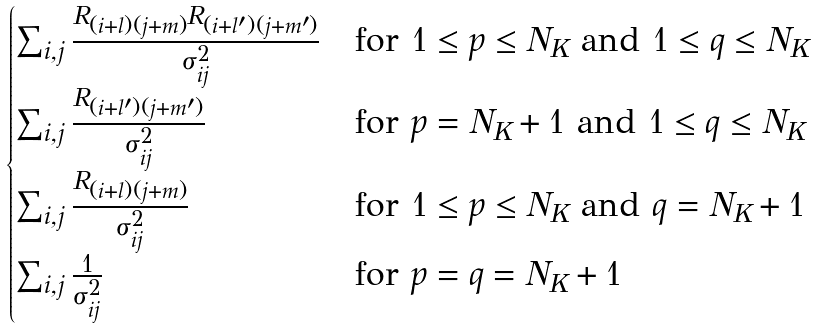Convert formula to latex. <formula><loc_0><loc_0><loc_500><loc_500>\begin{cases} \sum _ { i , j } \frac { R _ { ( i + l ) ( j + m ) } R _ { ( i + l ^ { \prime } ) ( j + m ^ { \prime } ) } } { \sigma _ { i j } ^ { 2 } } & \text {for $1 \leq p \leq N_{K}$ and $1 \leq q \leq N_{K}$} \\ \sum _ { i , j } \frac { R _ { ( i + l ^ { \prime } ) ( j + m ^ { \prime } ) } } { \sigma _ { i j } ^ { 2 } } & \text {for $p = N_{K} + 1$ and $1 \leq q \leq N_{K}$} \\ \sum _ { i , j } \frac { R _ { ( i + l ) ( j + m ) } } { \sigma _ { i j } ^ { 2 } } & \text {for $1 \leq p \leq N_{K}$ and $q = N_{K} + 1$} \\ \sum _ { i , j } \frac { 1 } { \sigma _ { i j } ^ { 2 } } & \text {for $p = q = N_{K} + 1$} \\ \end{cases}</formula> 